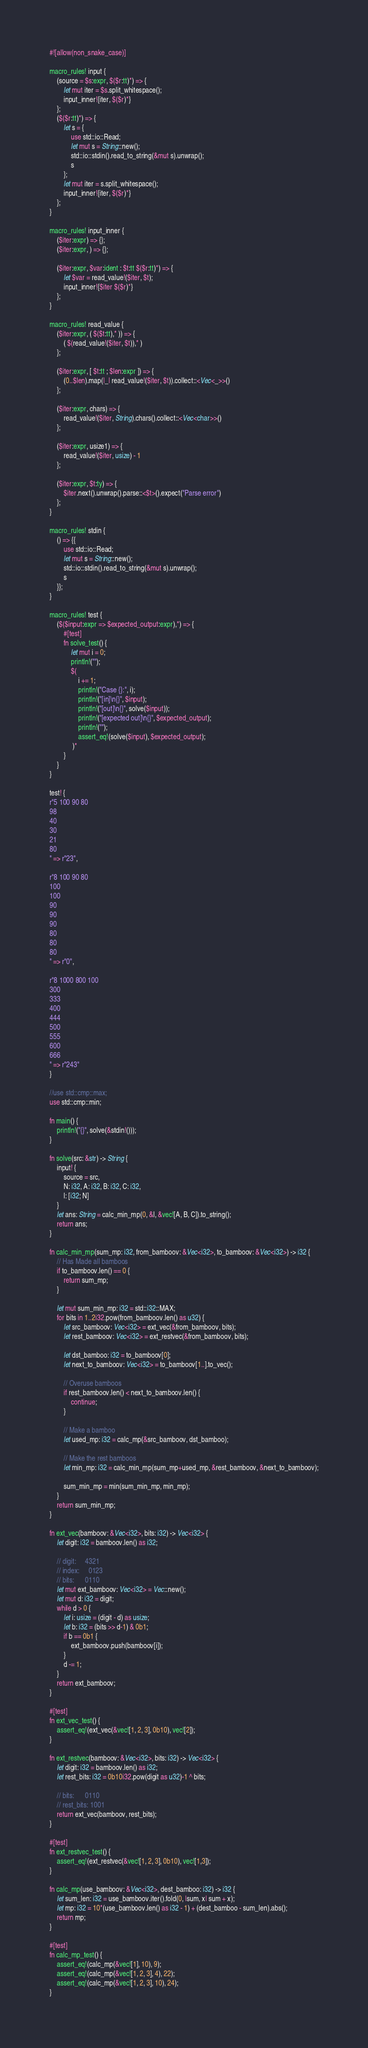Convert code to text. <code><loc_0><loc_0><loc_500><loc_500><_Rust_>#![allow(non_snake_case)]

macro_rules! input {
    (source = $s:expr, $($r:tt)*) => {
        let mut iter = $s.split_whitespace();
        input_inner!{iter, $($r)*}
    };
    ($($r:tt)*) => {
        let s = {
            use std::io::Read;
            let mut s = String::new();
            std::io::stdin().read_to_string(&mut s).unwrap();
            s
        };
        let mut iter = s.split_whitespace();
        input_inner!{iter, $($r)*}
    };
}

macro_rules! input_inner {
    ($iter:expr) => {};
    ($iter:expr, ) => {};

    ($iter:expr, $var:ident : $t:tt $($r:tt)*) => {
        let $var = read_value!($iter, $t);
        input_inner!{$iter $($r)*}
    };
}

macro_rules! read_value {
    ($iter:expr, ( $($t:tt),* )) => {
        ( $(read_value!($iter, $t)),* )
    };

    ($iter:expr, [ $t:tt ; $len:expr ]) => {
        (0..$len).map(|_| read_value!($iter, $t)).collect::<Vec<_>>()
    };

    ($iter:expr, chars) => {
        read_value!($iter, String).chars().collect::<Vec<char>>()
    };

    ($iter:expr, usize1) => {
        read_value!($iter, usize) - 1
    };

    ($iter:expr, $t:ty) => {
        $iter.next().unwrap().parse::<$t>().expect("Parse error")
    };
}

macro_rules! stdin {
    () => {{
        use std::io::Read;
        let mut s = String::new();
        std::io::stdin().read_to_string(&mut s).unwrap();
        s
    }};
}

macro_rules! test {
    ($($input:expr => $expected_output:expr),*) => {
        #[test]
        fn solve_test() {
            let mut i = 0;
            println!("");
            $(
                i += 1;
                println!("Case {}:", i);
                println!("[in]\n{}", $input);
                println!("[out]\n{}", solve($input));
                println!("[expected out]\n{}", $expected_output);
                println!("");
                assert_eq!(solve($input), $expected_output);
             )*
        }
    }
}

test! {
r"5 100 90 80
98
40
30
21
80
" => r"23",

r"8 100 90 80
100
100
90
90
90
80
80
80
" => r"0",

r"8 1000 800 100
300
333
400
444
500
555
600
666
" => r"243"
}

//use std::cmp::max;
use std::cmp::min;

fn main() {
    println!("{}", solve(&stdin!()));
}

fn solve(src: &str) -> String {
    input! {
        source = src,
        N: i32, A: i32, B: i32, C: i32,
        l: [i32; N]
    }
    let ans: String = calc_min_mp(0, &l, &vec![A, B, C]).to_string();
    return ans;
}

fn calc_min_mp(sum_mp: i32, from_bamboov: &Vec<i32>, to_bamboov: &Vec<i32>) -> i32 {
    // Has Made all bamboos
    if to_bamboov.len() == 0 {
        return sum_mp;
    }

    let mut sum_min_mp: i32 = std::i32::MAX;
    for bits in 1..2i32.pow(from_bamboov.len() as u32) {
        let src_bamboov: Vec<i32> = ext_vec(&from_bamboov, bits);
        let rest_bamboov: Vec<i32> = ext_restvec(&from_bamboov, bits);

        let dst_bamboo: i32 = to_bamboov[0];
        let next_to_bamboov: Vec<i32> = to_bamboov[1..].to_vec();

        // Overuse bamboos
        if rest_bamboov.len() < next_to_bamboov.len() {
            continue;
        }

        // Make a bamboo
        let used_mp: i32 = calc_mp(&src_bamboov, dst_bamboo);

        // Make the rest bamboos
        let min_mp: i32 = calc_min_mp(sum_mp+used_mp, &rest_bamboov, &next_to_bamboov);

        sum_min_mp = min(sum_min_mp, min_mp);
    }
    return sum_min_mp;
}

fn ext_vec(bamboov: &Vec<i32>, bits: i32) -> Vec<i32> {
    let digit: i32 = bamboov.len() as i32;

    // digit:     4321
    // index:     0123
    // bits:      0110
    let mut ext_bamboov: Vec<i32> = Vec::new();
    let mut d: i32 = digit;
    while d > 0 {
        let i: usize = (digit - d) as usize;
        let b: i32 = (bits >> d-1) & 0b1;
        if b == 0b1 {
            ext_bamboov.push(bamboov[i]);
        }
        d -= 1;
    }
    return ext_bamboov;
}

#[test]
fn ext_vec_test() {
    assert_eq!(ext_vec(&vec![1, 2, 3], 0b10), vec![2]);
}

fn ext_restvec(bamboov: &Vec<i32>, bits: i32) -> Vec<i32> {
    let digit: i32 = bamboov.len() as i32;
    let rest_bits: i32 = 0b10i32.pow(digit as u32)-1 ^ bits;

    // bits:      0110
    // rest_bits: 1001
    return ext_vec(bamboov, rest_bits);
}

#[test]
fn ext_restvec_test() {
    assert_eq!(ext_restvec(&vec![1, 2, 3], 0b10), vec![1,3]);
}

fn calc_mp(use_bamboov: &Vec<i32>, dest_bamboo: i32) -> i32 {
    let sum_len: i32 = use_bamboov.iter().fold(0, |sum, x| sum + x);
    let mp: i32 = 10*(use_bamboov.len() as i32 - 1) + (dest_bamboo - sum_len).abs();
    return mp;
}

#[test]
fn calc_mp_test() {
    assert_eq!(calc_mp(&vec![1], 10), 9);
    assert_eq!(calc_mp(&vec![1, 2, 3], 4), 22);
    assert_eq!(calc_mp(&vec![1, 2, 3], 10), 24);
}
</code> 